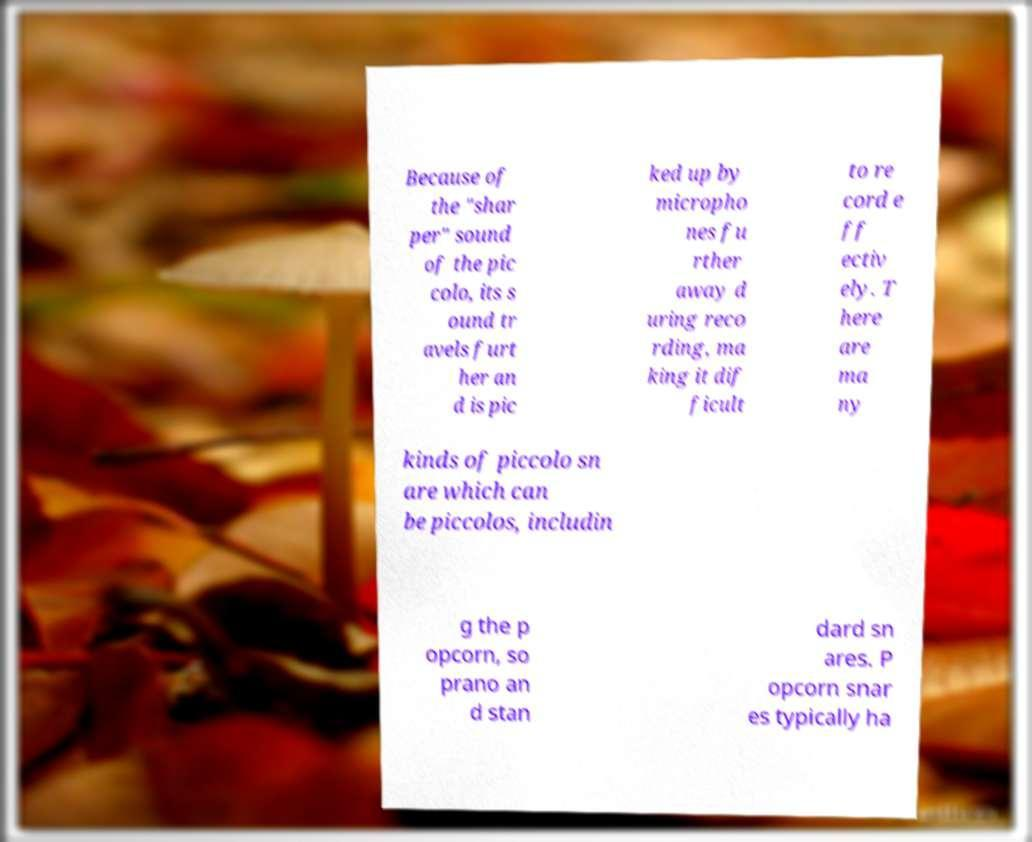Can you read and provide the text displayed in the image?This photo seems to have some interesting text. Can you extract and type it out for me? Because of the "shar per" sound of the pic colo, its s ound tr avels furt her an d is pic ked up by micropho nes fu rther away d uring reco rding, ma king it dif ficult to re cord e ff ectiv ely. T here are ma ny kinds of piccolo sn are which can be piccolos, includin g the p opcorn, so prano an d stan dard sn ares. P opcorn snar es typically ha 